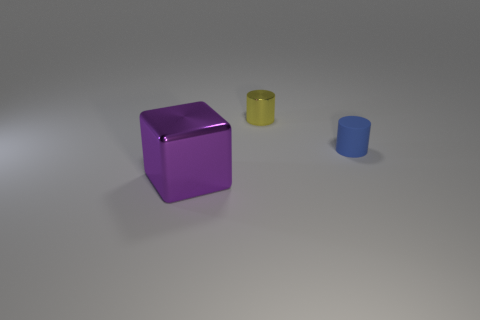Add 1 cyan shiny balls. How many objects exist? 4 Subtract all blocks. How many objects are left? 2 Subtract all blue matte cylinders. Subtract all tiny matte objects. How many objects are left? 1 Add 3 tiny blue matte things. How many tiny blue matte things are left? 4 Add 1 shiny cylinders. How many shiny cylinders exist? 2 Subtract 0 green cylinders. How many objects are left? 3 